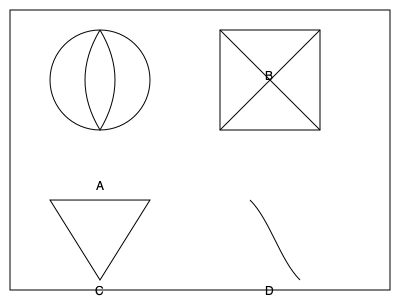As a cultural attaché organizing an international art exhibition, you come across these traditional patterns from different cultures. Match the pattern that most likely originates from Islamic geometric art: To identify the pattern most likely originating from Islamic geometric art, we need to consider the characteristics of Islamic art:

1. Islamic art often features geometric patterns and symmetry.
2. It typically avoids representational imagery of living beings.
3. Islamic patterns often include intricate interlacing designs.
4. Circular and star-like patterns are common in Islamic art.

Analyzing the given patterns:

A: This pattern shows a circular design with symmetrical curves, resembling a stylized flower or rosette. While it has symmetry, it's not as complex as typical Islamic patterns.

B: This pattern displays a square with diagonal lines forming an "X" shape. It's geometric but lacks the intricacy associated with Islamic art.

C: This pattern is a simple triangle, which is too basic to be characteristic of Islamic geometric art.

D: This pattern shows a curved line, possibly part of a larger arabesque design. While it could be found in Islamic art, it's not distinctively geometric.

Among these options, pattern A most closely resembles Islamic geometric art due to its circular symmetry and stylized, non-representational design. Islamic art often features rosette patterns similar to this, especially in architectural decorations.
Answer: A 